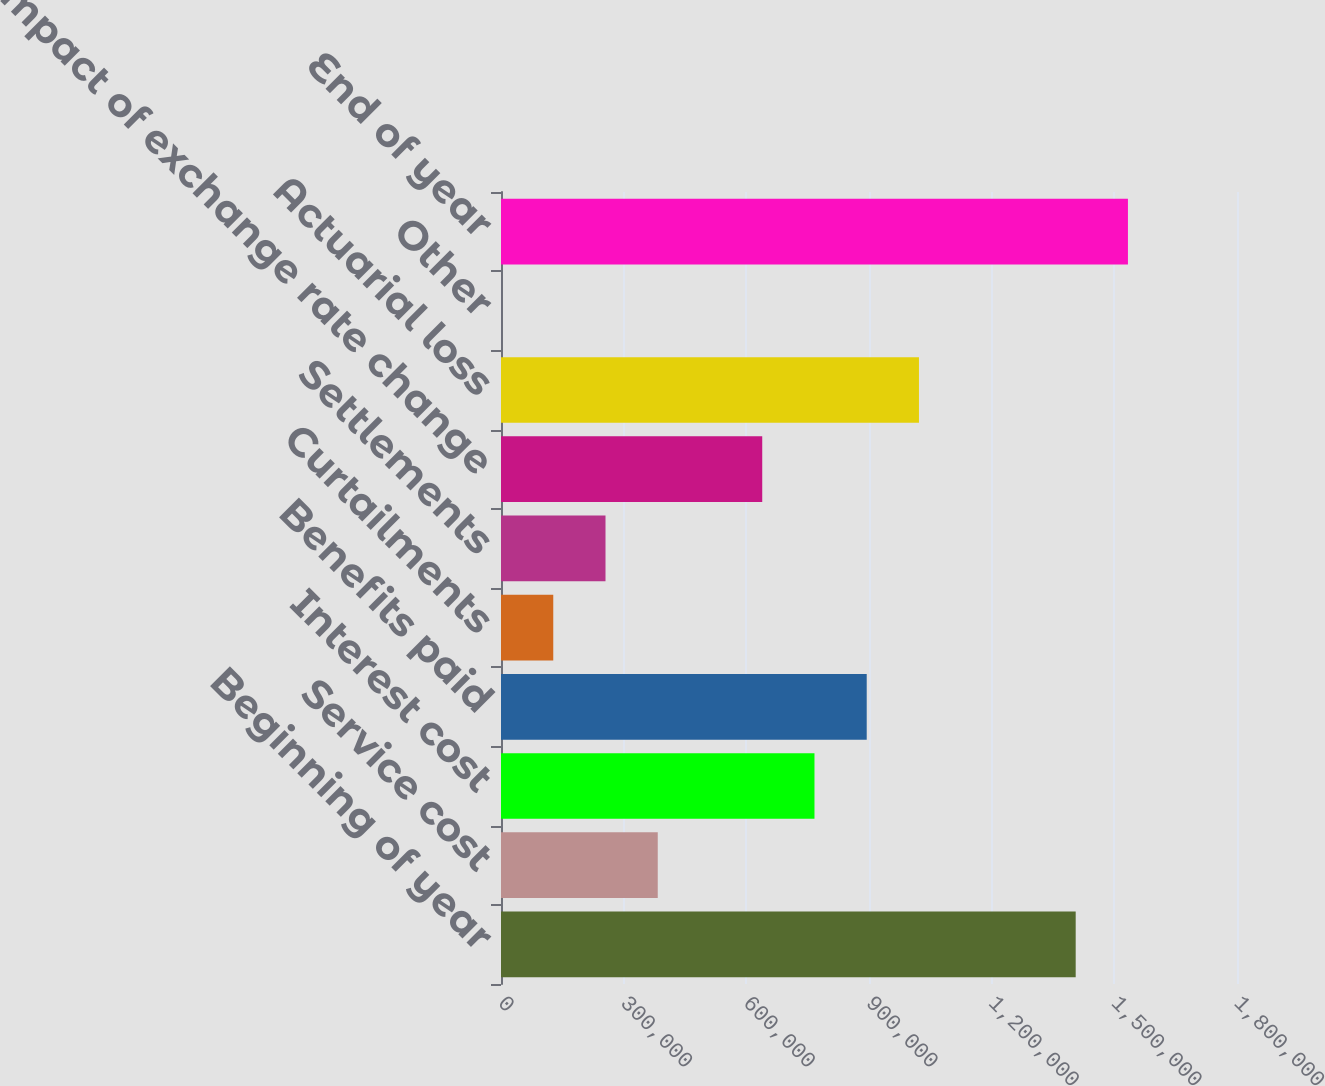Convert chart. <chart><loc_0><loc_0><loc_500><loc_500><bar_chart><fcel>Beginning of year<fcel>Service cost<fcel>Interest cost<fcel>Benefits paid<fcel>Curtailments<fcel>Settlements<fcel>Impact of exchange rate change<fcel>Actuarial loss<fcel>Other<fcel>End of year<nl><fcel>1.40549e+06<fcel>383348<fcel>766651<fcel>894419<fcel>127813<fcel>255580<fcel>638884<fcel>1.02219e+06<fcel>45<fcel>1.53326e+06<nl></chart> 